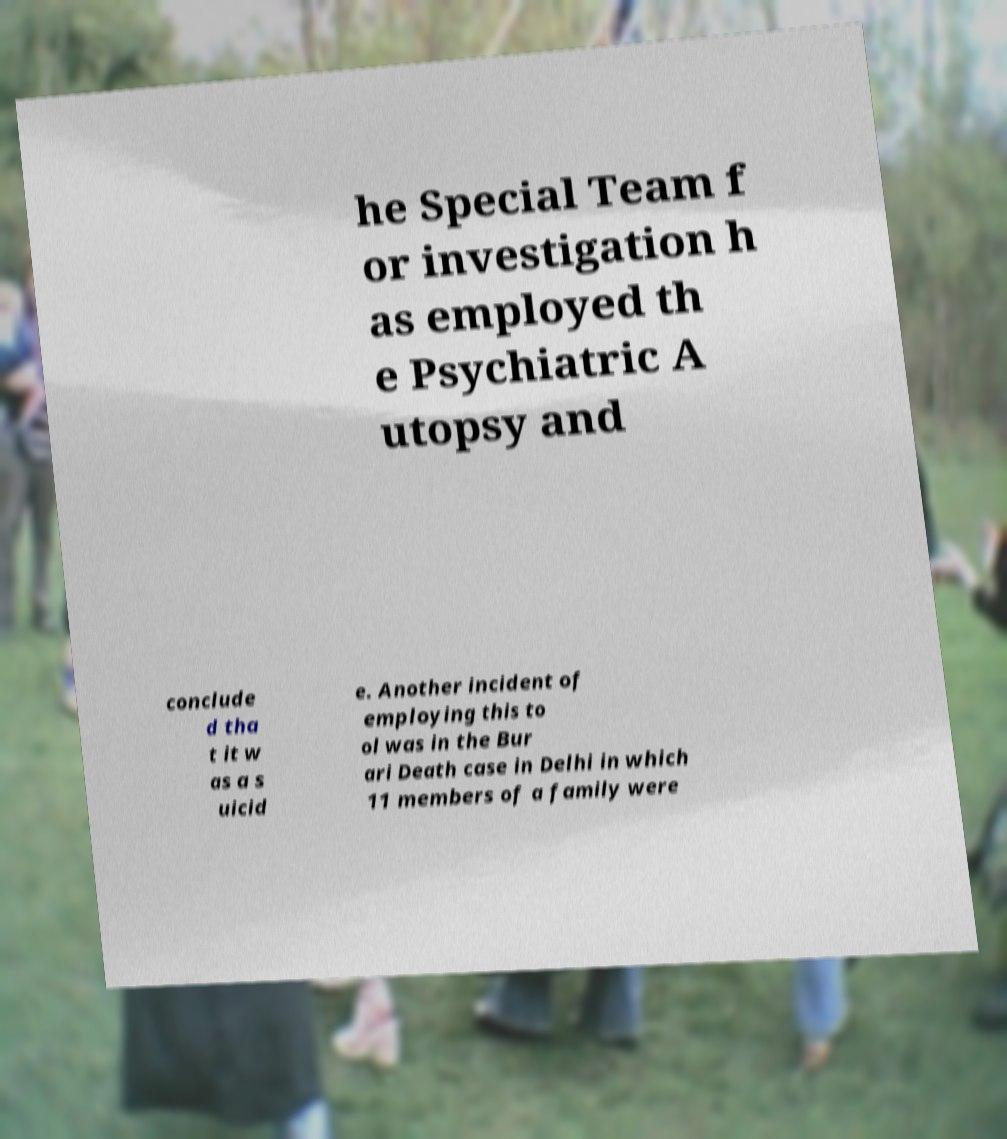There's text embedded in this image that I need extracted. Can you transcribe it verbatim? he Special Team f or investigation h as employed th e Psychiatric A utopsy and conclude d tha t it w as a s uicid e. Another incident of employing this to ol was in the Bur ari Death case in Delhi in which 11 members of a family were 